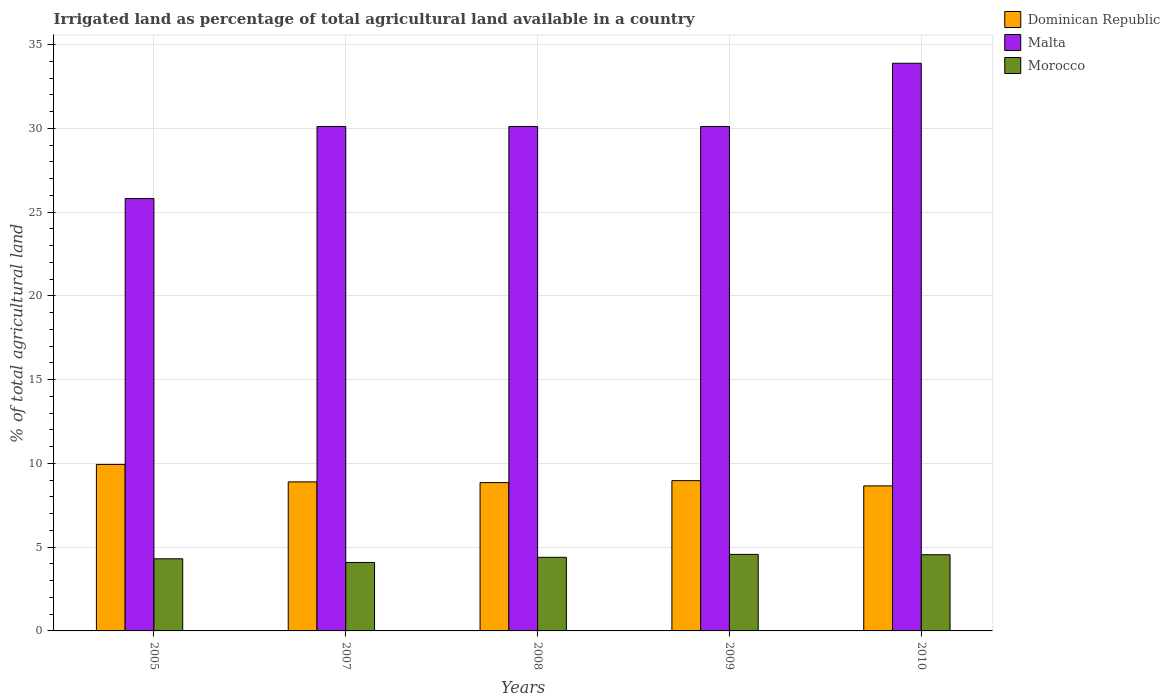How many different coloured bars are there?
Keep it short and to the point. 3. How many groups of bars are there?
Provide a succinct answer. 5. Are the number of bars per tick equal to the number of legend labels?
Make the answer very short. Yes. Are the number of bars on each tick of the X-axis equal?
Ensure brevity in your answer.  Yes. How many bars are there on the 1st tick from the right?
Make the answer very short. 3. In how many cases, is the number of bars for a given year not equal to the number of legend labels?
Your answer should be very brief. 0. What is the percentage of irrigated land in Morocco in 2009?
Keep it short and to the point. 4.57. Across all years, what is the maximum percentage of irrigated land in Malta?
Your answer should be very brief. 33.88. Across all years, what is the minimum percentage of irrigated land in Dominican Republic?
Your answer should be very brief. 8.66. In which year was the percentage of irrigated land in Malta minimum?
Provide a short and direct response. 2005. What is the total percentage of irrigated land in Malta in the graph?
Give a very brief answer. 150.01. What is the difference between the percentage of irrigated land in Malta in 2007 and that in 2010?
Keep it short and to the point. -3.77. What is the difference between the percentage of irrigated land in Malta in 2010 and the percentage of irrigated land in Dominican Republic in 2009?
Offer a terse response. 24.91. What is the average percentage of irrigated land in Malta per year?
Keep it short and to the point. 30. In the year 2010, what is the difference between the percentage of irrigated land in Morocco and percentage of irrigated land in Malta?
Make the answer very short. -29.33. In how many years, is the percentage of irrigated land in Malta greater than 25 %?
Ensure brevity in your answer.  5. What is the ratio of the percentage of irrigated land in Dominican Republic in 2005 to that in 2007?
Keep it short and to the point. 1.12. Is the percentage of irrigated land in Dominican Republic in 2005 less than that in 2007?
Your answer should be compact. No. Is the difference between the percentage of irrigated land in Morocco in 2008 and 2009 greater than the difference between the percentage of irrigated land in Malta in 2008 and 2009?
Make the answer very short. No. What is the difference between the highest and the second highest percentage of irrigated land in Morocco?
Offer a very short reply. 0.02. What is the difference between the highest and the lowest percentage of irrigated land in Malta?
Provide a succinct answer. 8.08. What does the 3rd bar from the left in 2009 represents?
Your response must be concise. Morocco. What does the 3rd bar from the right in 2008 represents?
Your answer should be very brief. Dominican Republic. Is it the case that in every year, the sum of the percentage of irrigated land in Dominican Republic and percentage of irrigated land in Malta is greater than the percentage of irrigated land in Morocco?
Your answer should be very brief. Yes. How many bars are there?
Give a very brief answer. 15. Are all the bars in the graph horizontal?
Your answer should be compact. No. Are the values on the major ticks of Y-axis written in scientific E-notation?
Offer a very short reply. No. Does the graph contain any zero values?
Make the answer very short. No. Does the graph contain grids?
Provide a short and direct response. Yes. How many legend labels are there?
Ensure brevity in your answer.  3. What is the title of the graph?
Offer a very short reply. Irrigated land as percentage of total agricultural land available in a country. Does "Honduras" appear as one of the legend labels in the graph?
Your answer should be very brief. No. What is the label or title of the X-axis?
Ensure brevity in your answer.  Years. What is the label or title of the Y-axis?
Give a very brief answer. % of total agricultural land. What is the % of total agricultural land in Dominican Republic in 2005?
Give a very brief answer. 9.94. What is the % of total agricultural land of Malta in 2005?
Provide a succinct answer. 25.81. What is the % of total agricultural land in Morocco in 2005?
Your response must be concise. 4.3. What is the % of total agricultural land in Dominican Republic in 2007?
Your response must be concise. 8.9. What is the % of total agricultural land of Malta in 2007?
Offer a very short reply. 30.11. What is the % of total agricultural land of Morocco in 2007?
Provide a succinct answer. 4.09. What is the % of total agricultural land of Dominican Republic in 2008?
Offer a very short reply. 8.85. What is the % of total agricultural land in Malta in 2008?
Your answer should be compact. 30.11. What is the % of total agricultural land in Morocco in 2008?
Make the answer very short. 4.39. What is the % of total agricultural land in Dominican Republic in 2009?
Your response must be concise. 8.97. What is the % of total agricultural land of Malta in 2009?
Make the answer very short. 30.11. What is the % of total agricultural land of Morocco in 2009?
Keep it short and to the point. 4.57. What is the % of total agricultural land in Dominican Republic in 2010?
Make the answer very short. 8.66. What is the % of total agricultural land in Malta in 2010?
Your answer should be very brief. 33.88. What is the % of total agricultural land in Morocco in 2010?
Make the answer very short. 4.55. Across all years, what is the maximum % of total agricultural land in Dominican Republic?
Your response must be concise. 9.94. Across all years, what is the maximum % of total agricultural land of Malta?
Offer a terse response. 33.88. Across all years, what is the maximum % of total agricultural land of Morocco?
Ensure brevity in your answer.  4.57. Across all years, what is the minimum % of total agricultural land in Dominican Republic?
Your response must be concise. 8.66. Across all years, what is the minimum % of total agricultural land in Malta?
Your answer should be very brief. 25.81. Across all years, what is the minimum % of total agricultural land in Morocco?
Your answer should be very brief. 4.09. What is the total % of total agricultural land of Dominican Republic in the graph?
Make the answer very short. 45.31. What is the total % of total agricultural land in Malta in the graph?
Your answer should be compact. 150.01. What is the total % of total agricultural land in Morocco in the graph?
Make the answer very short. 21.9. What is the difference between the % of total agricultural land of Dominican Republic in 2005 and that in 2007?
Ensure brevity in your answer.  1.04. What is the difference between the % of total agricultural land in Malta in 2005 and that in 2007?
Offer a terse response. -4.3. What is the difference between the % of total agricultural land of Morocco in 2005 and that in 2007?
Offer a terse response. 0.22. What is the difference between the % of total agricultural land of Dominican Republic in 2005 and that in 2008?
Make the answer very short. 1.09. What is the difference between the % of total agricultural land of Malta in 2005 and that in 2008?
Make the answer very short. -4.3. What is the difference between the % of total agricultural land of Morocco in 2005 and that in 2008?
Your answer should be compact. -0.09. What is the difference between the % of total agricultural land in Dominican Republic in 2005 and that in 2009?
Offer a terse response. 0.97. What is the difference between the % of total agricultural land in Malta in 2005 and that in 2009?
Make the answer very short. -4.3. What is the difference between the % of total agricultural land of Morocco in 2005 and that in 2009?
Your answer should be very brief. -0.26. What is the difference between the % of total agricultural land in Dominican Republic in 2005 and that in 2010?
Provide a succinct answer. 1.28. What is the difference between the % of total agricultural land of Malta in 2005 and that in 2010?
Your answer should be compact. -8.08. What is the difference between the % of total agricultural land in Morocco in 2005 and that in 2010?
Your answer should be compact. -0.24. What is the difference between the % of total agricultural land in Dominican Republic in 2007 and that in 2008?
Give a very brief answer. 0.04. What is the difference between the % of total agricultural land in Morocco in 2007 and that in 2008?
Your answer should be very brief. -0.31. What is the difference between the % of total agricultural land in Dominican Republic in 2007 and that in 2009?
Offer a very short reply. -0.07. What is the difference between the % of total agricultural land in Malta in 2007 and that in 2009?
Provide a short and direct response. 0. What is the difference between the % of total agricultural land in Morocco in 2007 and that in 2009?
Give a very brief answer. -0.48. What is the difference between the % of total agricultural land in Dominican Republic in 2007 and that in 2010?
Offer a terse response. 0.24. What is the difference between the % of total agricultural land in Malta in 2007 and that in 2010?
Ensure brevity in your answer.  -3.77. What is the difference between the % of total agricultural land in Morocco in 2007 and that in 2010?
Offer a very short reply. -0.46. What is the difference between the % of total agricultural land of Dominican Republic in 2008 and that in 2009?
Your response must be concise. -0.12. What is the difference between the % of total agricultural land in Malta in 2008 and that in 2009?
Provide a succinct answer. 0. What is the difference between the % of total agricultural land of Morocco in 2008 and that in 2009?
Offer a very short reply. -0.18. What is the difference between the % of total agricultural land of Dominican Republic in 2008 and that in 2010?
Your answer should be compact. 0.2. What is the difference between the % of total agricultural land in Malta in 2008 and that in 2010?
Give a very brief answer. -3.77. What is the difference between the % of total agricultural land in Morocco in 2008 and that in 2010?
Your answer should be compact. -0.16. What is the difference between the % of total agricultural land in Dominican Republic in 2009 and that in 2010?
Make the answer very short. 0.31. What is the difference between the % of total agricultural land in Malta in 2009 and that in 2010?
Offer a very short reply. -3.77. What is the difference between the % of total agricultural land of Morocco in 2009 and that in 2010?
Make the answer very short. 0.02. What is the difference between the % of total agricultural land of Dominican Republic in 2005 and the % of total agricultural land of Malta in 2007?
Keep it short and to the point. -20.17. What is the difference between the % of total agricultural land in Dominican Republic in 2005 and the % of total agricultural land in Morocco in 2007?
Keep it short and to the point. 5.85. What is the difference between the % of total agricultural land in Malta in 2005 and the % of total agricultural land in Morocco in 2007?
Your answer should be very brief. 21.72. What is the difference between the % of total agricultural land in Dominican Republic in 2005 and the % of total agricultural land in Malta in 2008?
Give a very brief answer. -20.17. What is the difference between the % of total agricultural land of Dominican Republic in 2005 and the % of total agricultural land of Morocco in 2008?
Provide a succinct answer. 5.55. What is the difference between the % of total agricultural land of Malta in 2005 and the % of total agricultural land of Morocco in 2008?
Your answer should be compact. 21.41. What is the difference between the % of total agricultural land of Dominican Republic in 2005 and the % of total agricultural land of Malta in 2009?
Offer a very short reply. -20.17. What is the difference between the % of total agricultural land in Dominican Republic in 2005 and the % of total agricultural land in Morocco in 2009?
Make the answer very short. 5.37. What is the difference between the % of total agricultural land of Malta in 2005 and the % of total agricultural land of Morocco in 2009?
Give a very brief answer. 21.24. What is the difference between the % of total agricultural land in Dominican Republic in 2005 and the % of total agricultural land in Malta in 2010?
Provide a succinct answer. -23.94. What is the difference between the % of total agricultural land of Dominican Republic in 2005 and the % of total agricultural land of Morocco in 2010?
Your answer should be compact. 5.39. What is the difference between the % of total agricultural land in Malta in 2005 and the % of total agricultural land in Morocco in 2010?
Give a very brief answer. 21.26. What is the difference between the % of total agricultural land of Dominican Republic in 2007 and the % of total agricultural land of Malta in 2008?
Ensure brevity in your answer.  -21.21. What is the difference between the % of total agricultural land in Dominican Republic in 2007 and the % of total agricultural land in Morocco in 2008?
Your answer should be very brief. 4.5. What is the difference between the % of total agricultural land of Malta in 2007 and the % of total agricultural land of Morocco in 2008?
Offer a terse response. 25.71. What is the difference between the % of total agricultural land of Dominican Republic in 2007 and the % of total agricultural land of Malta in 2009?
Provide a short and direct response. -21.21. What is the difference between the % of total agricultural land of Dominican Republic in 2007 and the % of total agricultural land of Morocco in 2009?
Your answer should be very brief. 4.33. What is the difference between the % of total agricultural land of Malta in 2007 and the % of total agricultural land of Morocco in 2009?
Offer a terse response. 25.54. What is the difference between the % of total agricultural land of Dominican Republic in 2007 and the % of total agricultural land of Malta in 2010?
Keep it short and to the point. -24.99. What is the difference between the % of total agricultural land in Dominican Republic in 2007 and the % of total agricultural land in Morocco in 2010?
Your response must be concise. 4.35. What is the difference between the % of total agricultural land in Malta in 2007 and the % of total agricultural land in Morocco in 2010?
Keep it short and to the point. 25.56. What is the difference between the % of total agricultural land of Dominican Republic in 2008 and the % of total agricultural land of Malta in 2009?
Offer a very short reply. -21.25. What is the difference between the % of total agricultural land in Dominican Republic in 2008 and the % of total agricultural land in Morocco in 2009?
Offer a terse response. 4.28. What is the difference between the % of total agricultural land in Malta in 2008 and the % of total agricultural land in Morocco in 2009?
Ensure brevity in your answer.  25.54. What is the difference between the % of total agricultural land of Dominican Republic in 2008 and the % of total agricultural land of Malta in 2010?
Your answer should be very brief. -25.03. What is the difference between the % of total agricultural land of Dominican Republic in 2008 and the % of total agricultural land of Morocco in 2010?
Make the answer very short. 4.3. What is the difference between the % of total agricultural land in Malta in 2008 and the % of total agricultural land in Morocco in 2010?
Make the answer very short. 25.56. What is the difference between the % of total agricultural land in Dominican Republic in 2009 and the % of total agricultural land in Malta in 2010?
Make the answer very short. -24.91. What is the difference between the % of total agricultural land in Dominican Republic in 2009 and the % of total agricultural land in Morocco in 2010?
Give a very brief answer. 4.42. What is the difference between the % of total agricultural land of Malta in 2009 and the % of total agricultural land of Morocco in 2010?
Provide a succinct answer. 25.56. What is the average % of total agricultural land in Dominican Republic per year?
Offer a very short reply. 9.06. What is the average % of total agricultural land of Malta per year?
Ensure brevity in your answer.  30. What is the average % of total agricultural land in Morocco per year?
Ensure brevity in your answer.  4.38. In the year 2005, what is the difference between the % of total agricultural land of Dominican Republic and % of total agricultural land of Malta?
Give a very brief answer. -15.87. In the year 2005, what is the difference between the % of total agricultural land of Dominican Republic and % of total agricultural land of Morocco?
Make the answer very short. 5.63. In the year 2005, what is the difference between the % of total agricultural land in Malta and % of total agricultural land in Morocco?
Your answer should be compact. 21.5. In the year 2007, what is the difference between the % of total agricultural land of Dominican Republic and % of total agricultural land of Malta?
Your answer should be compact. -21.21. In the year 2007, what is the difference between the % of total agricultural land of Dominican Republic and % of total agricultural land of Morocco?
Keep it short and to the point. 4.81. In the year 2007, what is the difference between the % of total agricultural land in Malta and % of total agricultural land in Morocco?
Your answer should be compact. 26.02. In the year 2008, what is the difference between the % of total agricultural land in Dominican Republic and % of total agricultural land in Malta?
Provide a short and direct response. -21.25. In the year 2008, what is the difference between the % of total agricultural land in Dominican Republic and % of total agricultural land in Morocco?
Keep it short and to the point. 4.46. In the year 2008, what is the difference between the % of total agricultural land in Malta and % of total agricultural land in Morocco?
Offer a terse response. 25.71. In the year 2009, what is the difference between the % of total agricultural land of Dominican Republic and % of total agricultural land of Malta?
Provide a succinct answer. -21.14. In the year 2009, what is the difference between the % of total agricultural land in Dominican Republic and % of total agricultural land in Morocco?
Offer a terse response. 4.4. In the year 2009, what is the difference between the % of total agricultural land in Malta and % of total agricultural land in Morocco?
Your response must be concise. 25.54. In the year 2010, what is the difference between the % of total agricultural land in Dominican Republic and % of total agricultural land in Malta?
Provide a short and direct response. -25.23. In the year 2010, what is the difference between the % of total agricultural land in Dominican Republic and % of total agricultural land in Morocco?
Ensure brevity in your answer.  4.11. In the year 2010, what is the difference between the % of total agricultural land in Malta and % of total agricultural land in Morocco?
Keep it short and to the point. 29.33. What is the ratio of the % of total agricultural land in Dominican Republic in 2005 to that in 2007?
Make the answer very short. 1.12. What is the ratio of the % of total agricultural land in Malta in 2005 to that in 2007?
Provide a short and direct response. 0.86. What is the ratio of the % of total agricultural land in Morocco in 2005 to that in 2007?
Offer a terse response. 1.05. What is the ratio of the % of total agricultural land of Dominican Republic in 2005 to that in 2008?
Your response must be concise. 1.12. What is the ratio of the % of total agricultural land of Malta in 2005 to that in 2008?
Your response must be concise. 0.86. What is the ratio of the % of total agricultural land of Dominican Republic in 2005 to that in 2009?
Your answer should be compact. 1.11. What is the ratio of the % of total agricultural land in Morocco in 2005 to that in 2009?
Keep it short and to the point. 0.94. What is the ratio of the % of total agricultural land in Dominican Republic in 2005 to that in 2010?
Your answer should be very brief. 1.15. What is the ratio of the % of total agricultural land in Malta in 2005 to that in 2010?
Ensure brevity in your answer.  0.76. What is the ratio of the % of total agricultural land in Morocco in 2005 to that in 2010?
Offer a terse response. 0.95. What is the ratio of the % of total agricultural land in Dominican Republic in 2007 to that in 2008?
Provide a short and direct response. 1. What is the ratio of the % of total agricultural land in Malta in 2007 to that in 2008?
Provide a succinct answer. 1. What is the ratio of the % of total agricultural land of Morocco in 2007 to that in 2008?
Make the answer very short. 0.93. What is the ratio of the % of total agricultural land of Morocco in 2007 to that in 2009?
Your answer should be compact. 0.89. What is the ratio of the % of total agricultural land of Dominican Republic in 2007 to that in 2010?
Provide a short and direct response. 1.03. What is the ratio of the % of total agricultural land of Malta in 2007 to that in 2010?
Offer a terse response. 0.89. What is the ratio of the % of total agricultural land in Morocco in 2007 to that in 2010?
Your answer should be compact. 0.9. What is the ratio of the % of total agricultural land of Morocco in 2008 to that in 2009?
Ensure brevity in your answer.  0.96. What is the ratio of the % of total agricultural land of Dominican Republic in 2008 to that in 2010?
Your answer should be very brief. 1.02. What is the ratio of the % of total agricultural land of Malta in 2008 to that in 2010?
Offer a terse response. 0.89. What is the ratio of the % of total agricultural land of Morocco in 2008 to that in 2010?
Your response must be concise. 0.97. What is the ratio of the % of total agricultural land in Dominican Republic in 2009 to that in 2010?
Keep it short and to the point. 1.04. What is the ratio of the % of total agricultural land in Malta in 2009 to that in 2010?
Your answer should be compact. 0.89. What is the difference between the highest and the second highest % of total agricultural land in Dominican Republic?
Your answer should be very brief. 0.97. What is the difference between the highest and the second highest % of total agricultural land in Malta?
Give a very brief answer. 3.77. What is the difference between the highest and the second highest % of total agricultural land of Morocco?
Your response must be concise. 0.02. What is the difference between the highest and the lowest % of total agricultural land in Dominican Republic?
Make the answer very short. 1.28. What is the difference between the highest and the lowest % of total agricultural land in Malta?
Your answer should be very brief. 8.08. What is the difference between the highest and the lowest % of total agricultural land in Morocco?
Offer a terse response. 0.48. 